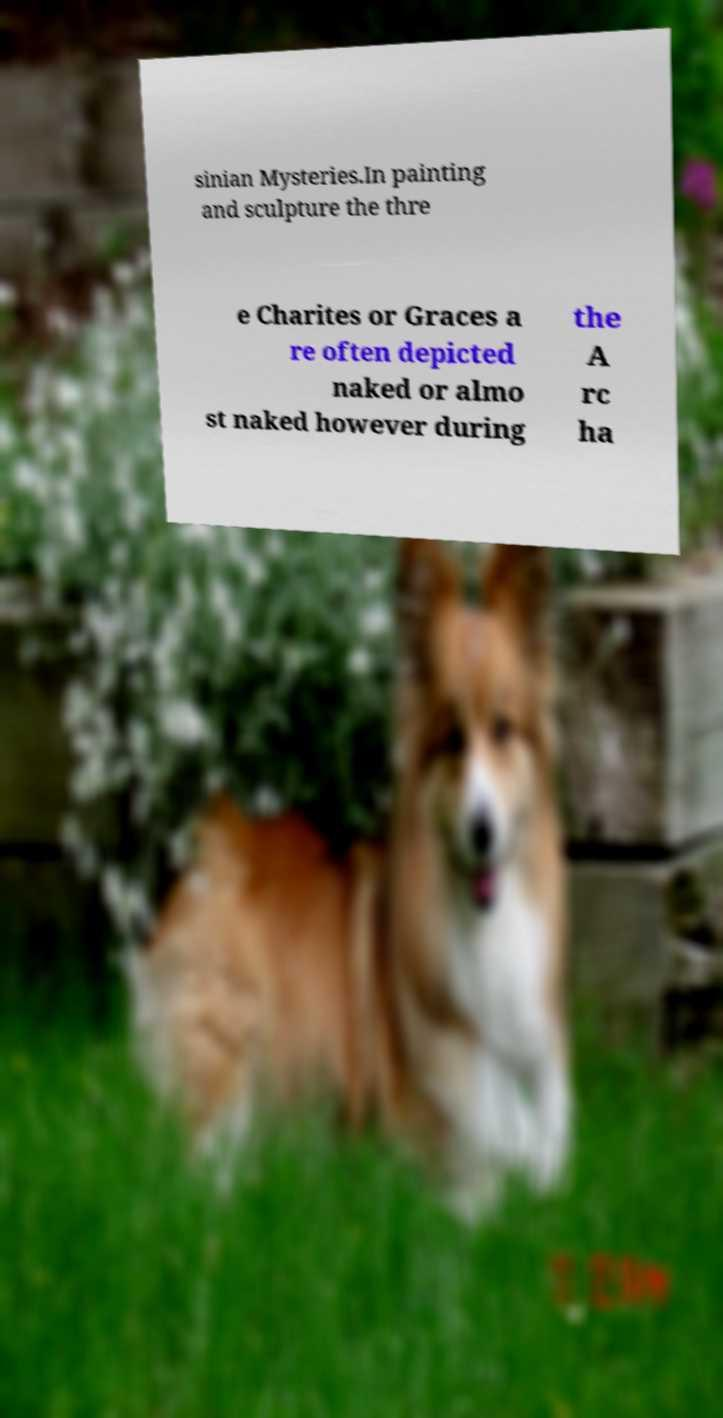Please identify and transcribe the text found in this image. sinian Mysteries.In painting and sculpture the thre e Charites or Graces a re often depicted naked or almo st naked however during the A rc ha 